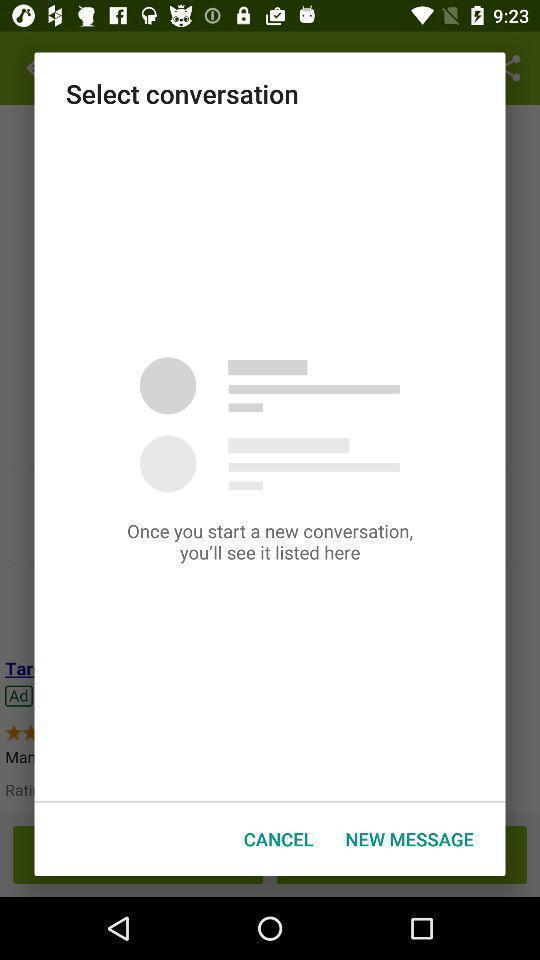Give me a narrative description of this picture. Popup of the page to update the message version. 